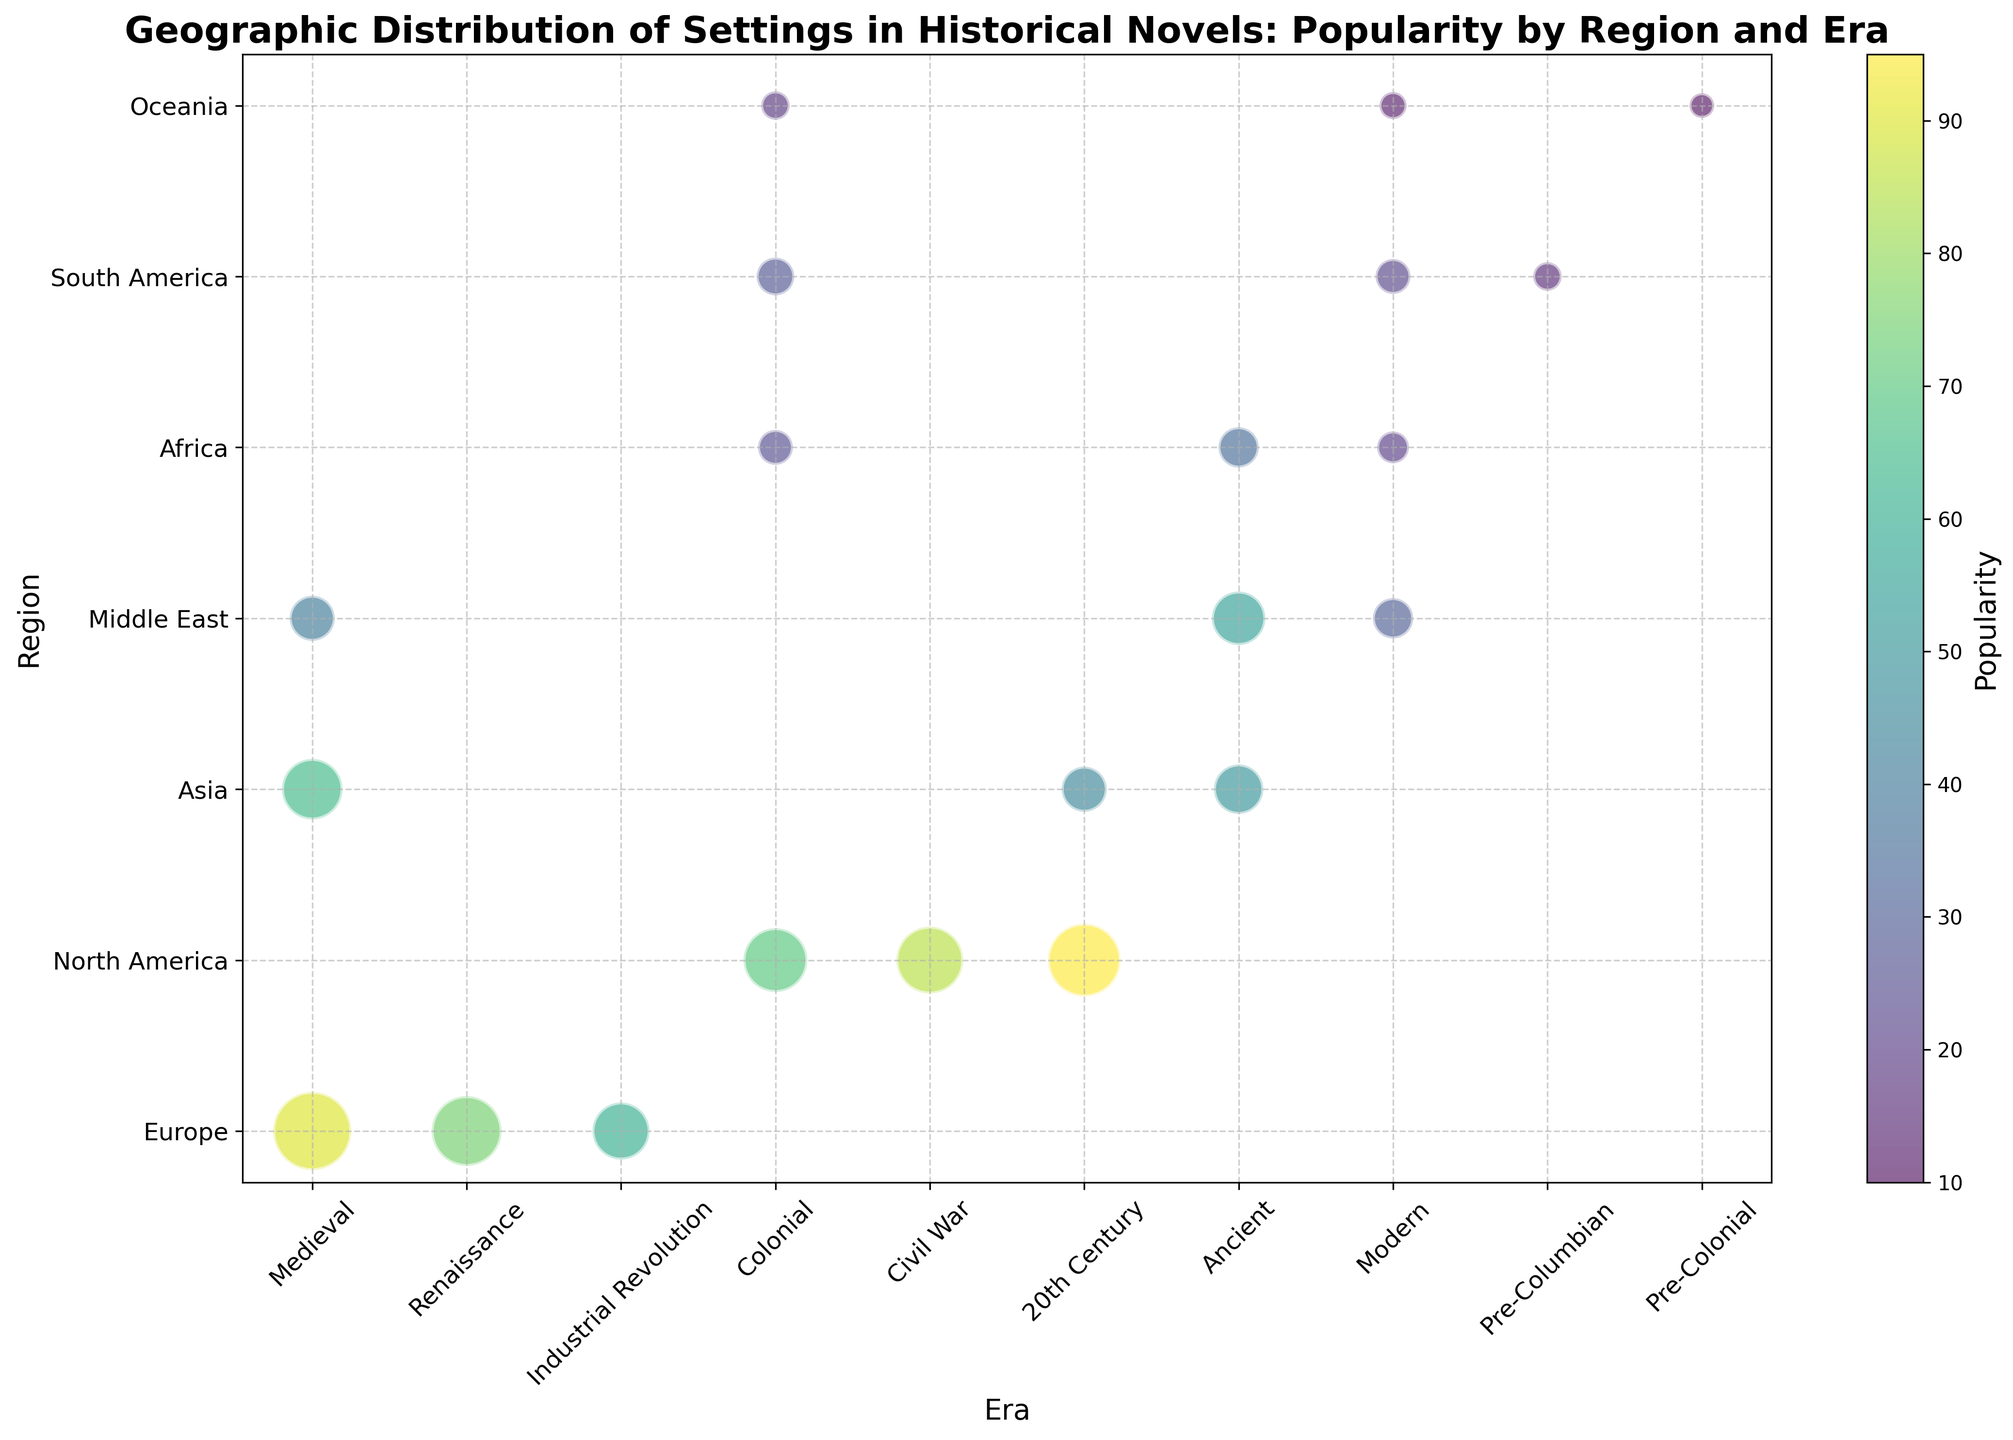What era in Europe has the highest popularity? Look for the bubble in the Europe row with the darkest color or highest value on the color bar. The Medieval era has the darkest bubble, corresponding to a popularity of 90.
Answer: Medieval Which region in North America has the highest number of novels? Compare the sizes of the bubbles in the North America row. The 20th Century bubble is the largest, representing the highest number of novels at 130.
Answer: 20th Century Which two regions have the lowest popularity during the Modern era? Identify the bubbles in the Modern era column and compare their colors using the color bar. Africa and Oceania have the lightest bubbles, indicating the lowest popularity values of 20 and 12.
Answer: Africa and Oceania Which region and era combination has a popularity of 55 with 70 novels? Find the bubble with the corresponding size and color around the value of 55 on the color bar. This bubble is located in the Middle East row within the Ancient column.
Answer: Middle East, Ancient What is the difference in popularity between the North American 20th Century and Asian 20th Century novels? Identify the popularity values for North American 20th Century (95) and Asian 20th Century (45). Subtract the latter from the former to find the difference (95 - 45 = 50).
Answer: 50 Which region shows a decline in popularity from the Colonial era to the Modern era? Compare the colors of the bubbles in the Colonial and Modern columns. Africa shows a decline from 25 (Colonial) to 20 (Modern).
Answer: Africa What is the combined number of novels set in the Renaissance and Industrial Revolution eras in Europe? Locate the number of novels for the Renaissance (120) and add it to the number of novels for the Industrial Revolution (80). The total is 120 + 80 = 200.
Answer: 200 Which era in the Middle East has the lowest number of novels? Compare the sizes of the bubbles in the Middle East row. The Modern era bubble is the smallest with 40 novels.
Answer: Modern What is the average popularity value across all eras in Asia? Identify the popularity values for the Asian eras: Ancient (50), Medieval (65), and 20th Century (45). Calculate the average: (50 + 65 + 45) / 3 ≈ 53.33.
Answer: 53.33 How many regions have a popularity above 70 in any era? Sum the number of unique regions with bubbles having color indicating popularity above 70 (darker shades). These regions are Europe (Medieval, Renaissance), North America (Civil War, 20th Century). The total is 2.
Answer: 2 